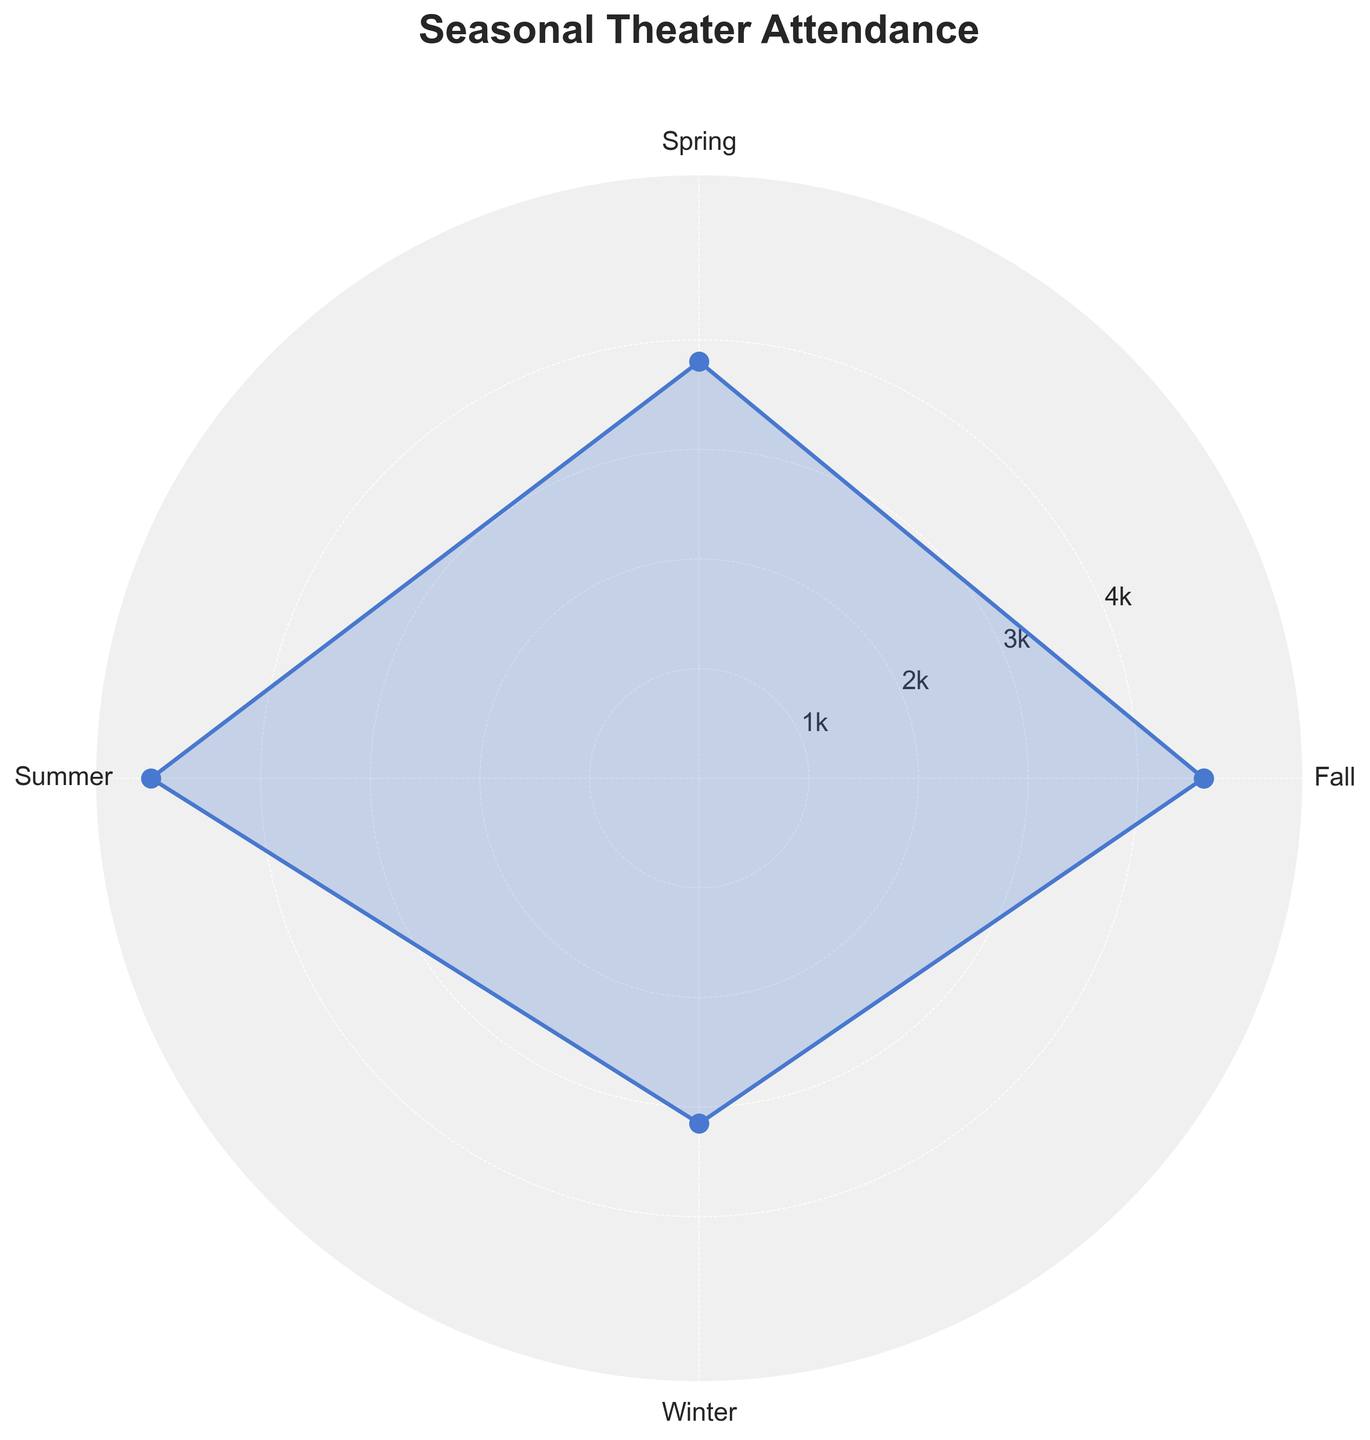What's the title of the figure? The title of the figure is displayed at the top, in bold and larger font.
Answer: Seasonal Theater Attendance Which season has the highest average attendance? By looking at the heights of the sections in the rose chart, the section with the highest average attendance is clearly labeled and visually the largest.
Answer: Summer What's the average attendance for Winter? Find the value directly indicated by the line for Winter on the rose chart and refer to the y-axis for the exact number.
Answer: 3150 What's the difference in average attendance between Summer and Winter? Subtract the average attendance value for Winter from that of Summer. Summer has the highest value on the chart and Winter has one of the lower values.
Answer: 5000 - 3150 = 1850 How many seasons are compared on the chart? Count the number of labeled sections or tick marks on the chart corresponding to different seasons.
Answer: 4 Which seasons have an average attendance around 4000? Look at the labeled values and sections which lie around the 4000 mark on the y-axis.
Answer: Spring and Fall Is the average attendance for Fall greater than that for Spring? Compare the height or value of the Fall section against the Spring section on the rose chart.
Answer: No Are there any seasons with an average attendance below 3200? Identify any sections on the chart that have values below 3200.
Answer: Yes, Winter Which season's average attendance is closest to 4600? Find the section on the rose chart that has a value closest to 4600 by comparing the heights or radial distance from the center.
Answer: Fall What is the shape of the plot? Describe the overall plot type and appearance as seen in the figure.
Answer: Polar/Rose Chart 